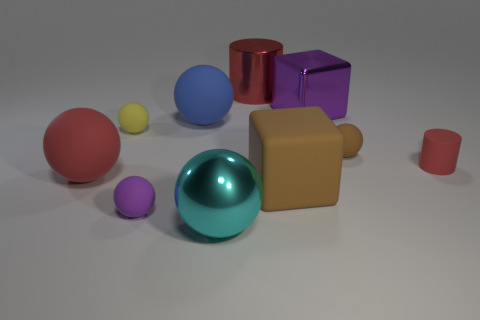How is the lighting affecting the appearance of the objects? The lighting in the image is soft and diffused, casting gentle shadows and subtly highlighting the contours and textures of each object, giving the scene a calm, realistic look. 